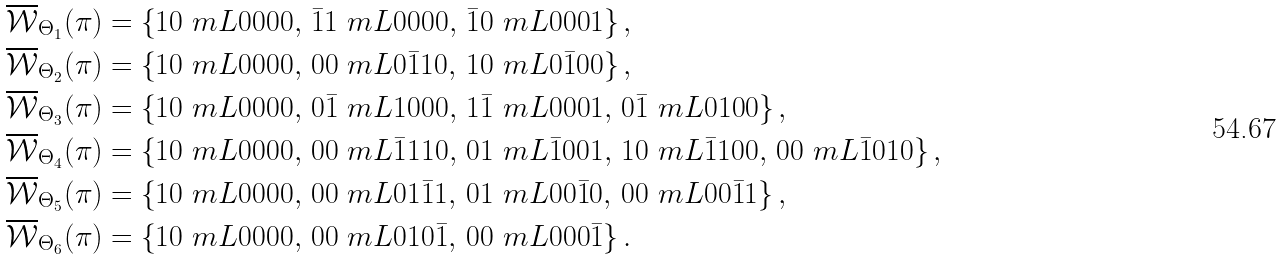<formula> <loc_0><loc_0><loc_500><loc_500>\overline { \mathcal { W } } _ { \Theta _ { 1 } } ( \pi ) & = \left \{ 1 0 \ m L 0 0 0 0 , \, \bar { 1 } 1 \ m L 0 0 0 0 , \, \bar { 1 } 0 \ m L 0 0 0 1 \right \} , \\ \overline { \mathcal { W } } _ { \Theta _ { 2 } } ( \pi ) & = \left \{ 1 0 \ m L 0 0 0 0 , \, 0 0 \ m L 0 { \bar { 1 } } 1 0 , \, 1 0 \ m L 0 { \bar { 1 } } 0 0 \right \} , \\ \overline { \mathcal { W } } _ { \Theta _ { 3 } } ( \pi ) & = \left \{ 1 0 \ m L 0 0 0 0 , \, 0 \bar { 1 } \ m L 1 0 0 0 , \, 1 \bar { 1 } \ m L 0 0 0 1 , \, 0 \bar { 1 } \ m L 0 1 0 0 \right \} , \\ \overline { \mathcal { W } } _ { \Theta _ { 4 } } ( \pi ) & = \left \{ 1 0 \ m L 0 0 0 0 , \, 0 0 \ m L { \bar { 1 } } 1 1 0 , \, 0 1 \ m L { \bar { 1 } } 0 0 1 , \, 1 0 \ m L { \bar { 1 } } 1 0 0 , \, 0 0 \ m L { \bar { 1 } } 0 1 0 \right \} , \\ \overline { \mathcal { W } } _ { \Theta _ { 5 } } ( \pi ) & = \left \{ 1 0 \ m L 0 0 0 0 , \, 0 0 \ m L 0 1 { \bar { 1 } } 1 , \, 0 1 \ m L 0 0 { \bar { 1 } } 0 , \, 0 0 \ m L 0 0 { \bar { 1 } } 1 \right \} , \\ \overline { \mathcal { W } } _ { \Theta _ { 6 } } ( \pi ) & = \left \{ 1 0 \ m L 0 0 0 0 , \, 0 0 \ m L 0 1 0 { \bar { 1 } } , \, 0 0 \ m L 0 0 0 { \bar { 1 } } \right \} .</formula> 